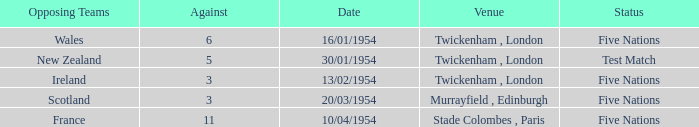Parse the table in full. {'header': ['Opposing Teams', 'Against', 'Date', 'Venue', 'Status'], 'rows': [['Wales', '6', '16/01/1954', 'Twickenham , London', 'Five Nations'], ['New Zealand', '5', '30/01/1954', 'Twickenham , London', 'Test Match'], ['Ireland', '3', '13/02/1954', 'Twickenham , London', 'Five Nations'], ['Scotland', '3', '20/03/1954', 'Murrayfield , Edinburgh', 'Five Nations'], ['France', '11', '10/04/1954', 'Stade Colombes , Paris', 'Five Nations']]} At which place was there a resistance of 11? Stade Colombes , Paris. 